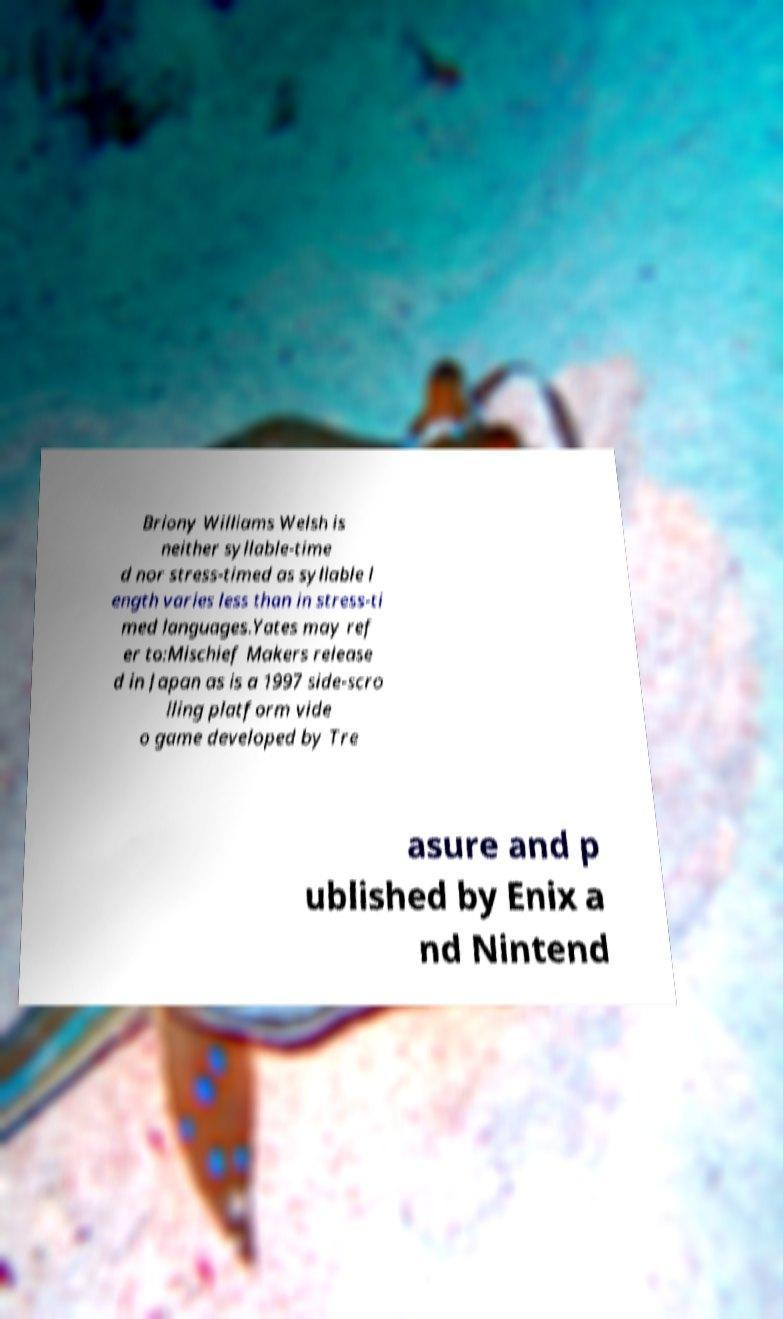Please read and relay the text visible in this image. What does it say? Briony Williams Welsh is neither syllable-time d nor stress-timed as syllable l ength varies less than in stress-ti med languages.Yates may ref er to:Mischief Makers release d in Japan as is a 1997 side-scro lling platform vide o game developed by Tre asure and p ublished by Enix a nd Nintend 